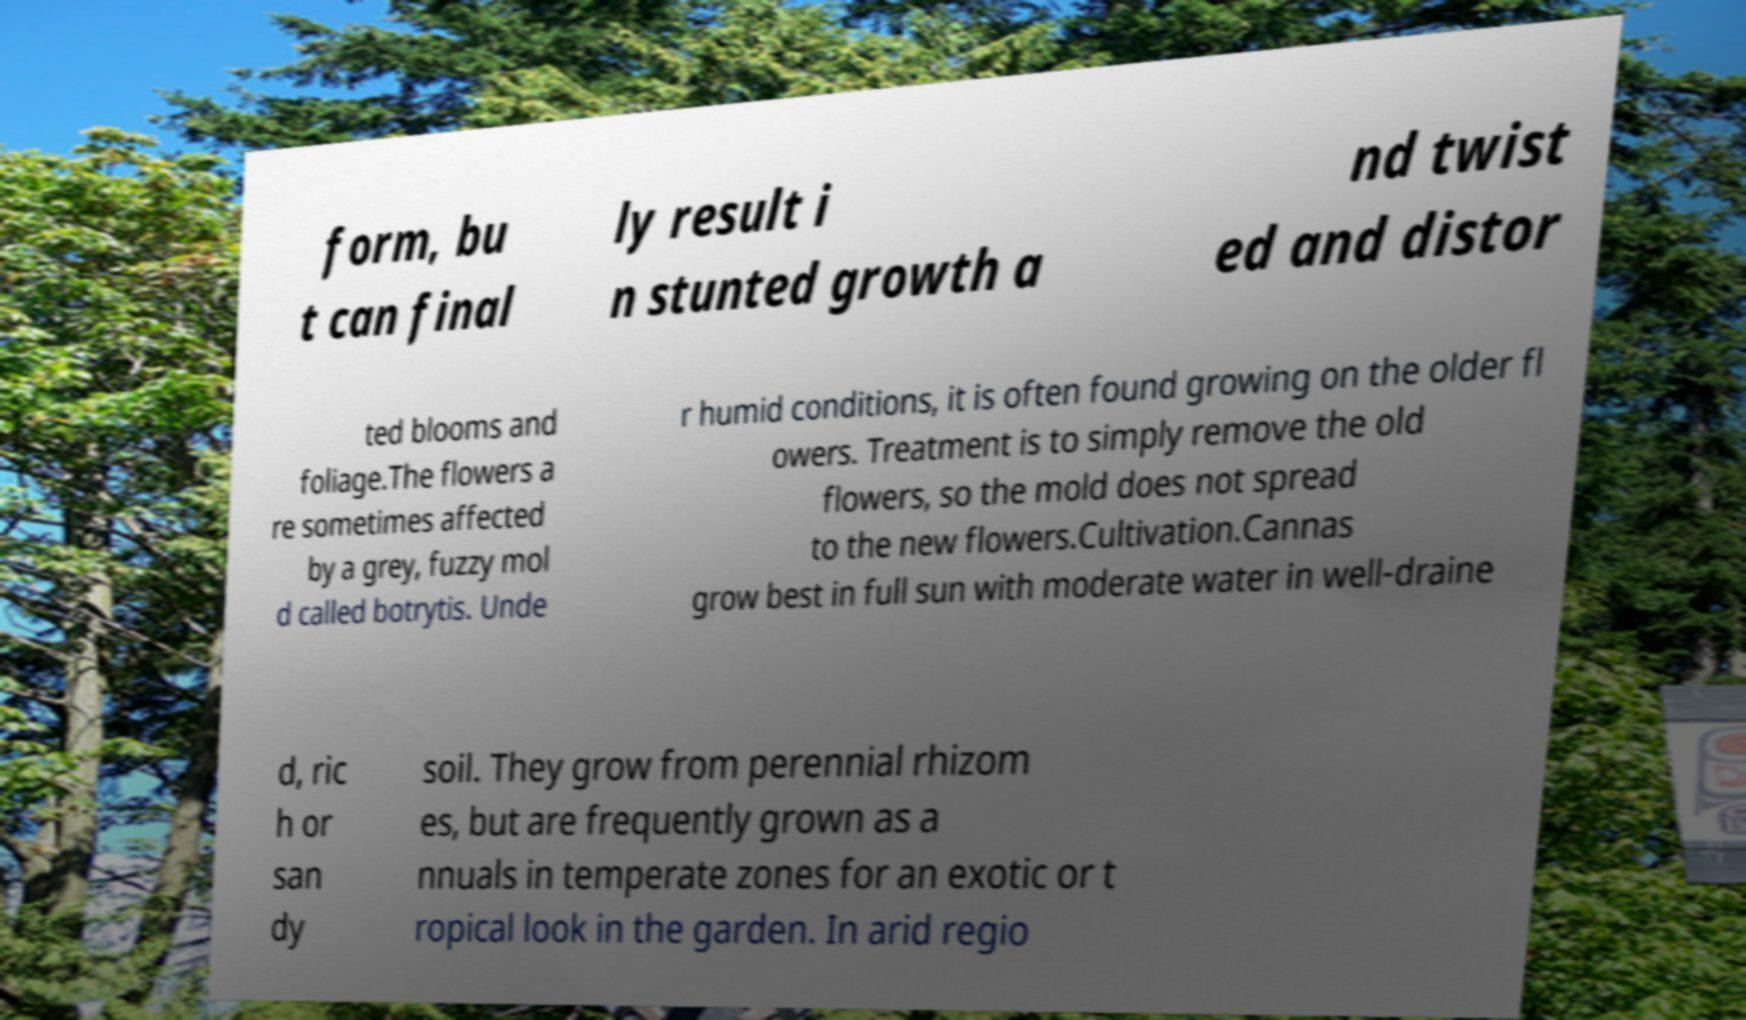Could you extract and type out the text from this image? form, bu t can final ly result i n stunted growth a nd twist ed and distor ted blooms and foliage.The flowers a re sometimes affected by a grey, fuzzy mol d called botrytis. Unde r humid conditions, it is often found growing on the older fl owers. Treatment is to simply remove the old flowers, so the mold does not spread to the new flowers.Cultivation.Cannas grow best in full sun with moderate water in well-draine d, ric h or san dy soil. They grow from perennial rhizom es, but are frequently grown as a nnuals in temperate zones for an exotic or t ropical look in the garden. In arid regio 